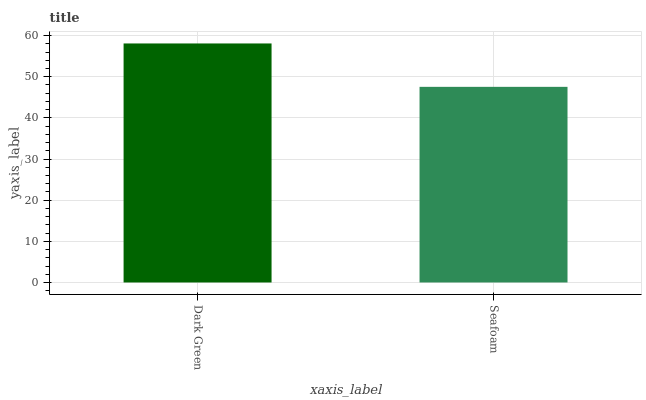Is Seafoam the minimum?
Answer yes or no. Yes. Is Dark Green the maximum?
Answer yes or no. Yes. Is Seafoam the maximum?
Answer yes or no. No. Is Dark Green greater than Seafoam?
Answer yes or no. Yes. Is Seafoam less than Dark Green?
Answer yes or no. Yes. Is Seafoam greater than Dark Green?
Answer yes or no. No. Is Dark Green less than Seafoam?
Answer yes or no. No. Is Dark Green the high median?
Answer yes or no. Yes. Is Seafoam the low median?
Answer yes or no. Yes. Is Seafoam the high median?
Answer yes or no. No. Is Dark Green the low median?
Answer yes or no. No. 